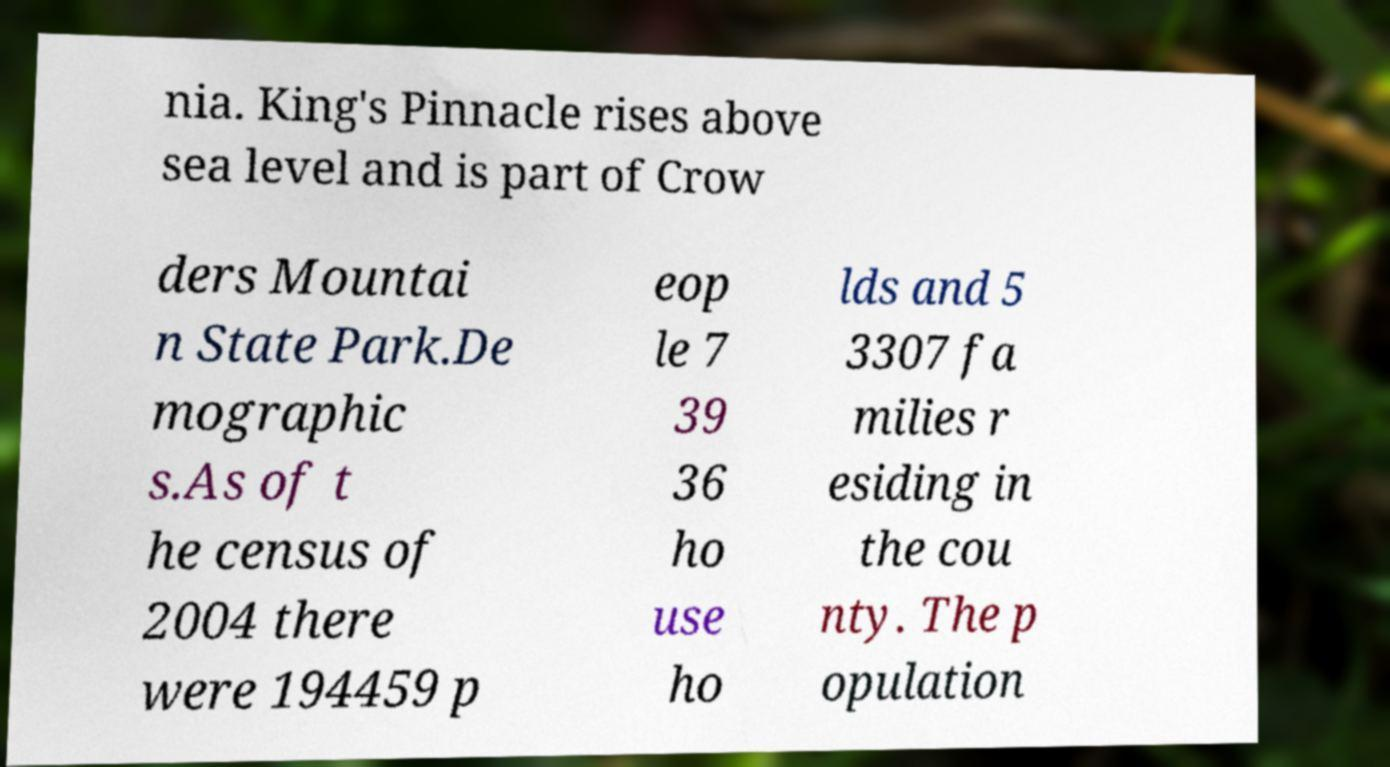Could you extract and type out the text from this image? nia. King's Pinnacle rises above sea level and is part of Crow ders Mountai n State Park.De mographic s.As of t he census of 2004 there were 194459 p eop le 7 39 36 ho use ho lds and 5 3307 fa milies r esiding in the cou nty. The p opulation 